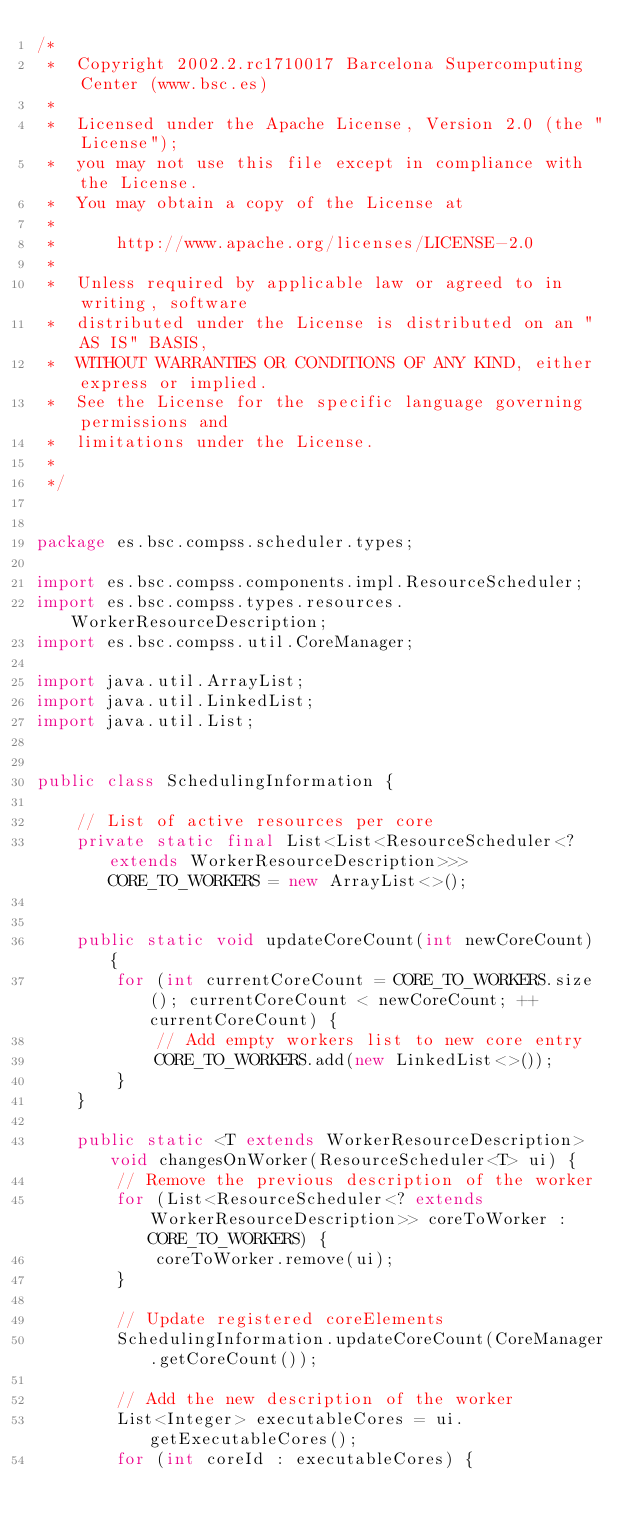<code> <loc_0><loc_0><loc_500><loc_500><_Java_>/*         
 *  Copyright 2002.2.rc1710017 Barcelona Supercomputing Center (www.bsc.es)
 *
 *  Licensed under the Apache License, Version 2.0 (the "License");
 *  you may not use this file except in compliance with the License.
 *  You may obtain a copy of the License at
 *
 *      http://www.apache.org/licenses/LICENSE-2.0
 *
 *  Unless required by applicable law or agreed to in writing, software
 *  distributed under the License is distributed on an "AS IS" BASIS,
 *  WITHOUT WARRANTIES OR CONDITIONS OF ANY KIND, either express or implied.
 *  See the License for the specific language governing permissions and
 *  limitations under the License.
 *
 */


package es.bsc.compss.scheduler.types;

import es.bsc.compss.components.impl.ResourceScheduler;
import es.bsc.compss.types.resources.WorkerResourceDescription;
import es.bsc.compss.util.CoreManager;

import java.util.ArrayList;
import java.util.LinkedList;
import java.util.List;


public class SchedulingInformation {

    // List of active resources per core
    private static final List<List<ResourceScheduler<? extends WorkerResourceDescription>>> CORE_TO_WORKERS = new ArrayList<>();


    public static void updateCoreCount(int newCoreCount) {
        for (int currentCoreCount = CORE_TO_WORKERS.size(); currentCoreCount < newCoreCount; ++currentCoreCount) {
            // Add empty workers list to new core entry
            CORE_TO_WORKERS.add(new LinkedList<>());
        }
    }

    public static <T extends WorkerResourceDescription> void changesOnWorker(ResourceScheduler<T> ui) {
        // Remove the previous description of the worker
        for (List<ResourceScheduler<? extends WorkerResourceDescription>> coreToWorker : CORE_TO_WORKERS) {
            coreToWorker.remove(ui);
        }

        // Update registered coreElements
        SchedulingInformation.updateCoreCount(CoreManager.getCoreCount());

        // Add the new description of the worker
        List<Integer> executableCores = ui.getExecutableCores();
        for (int coreId : executableCores) {</code> 